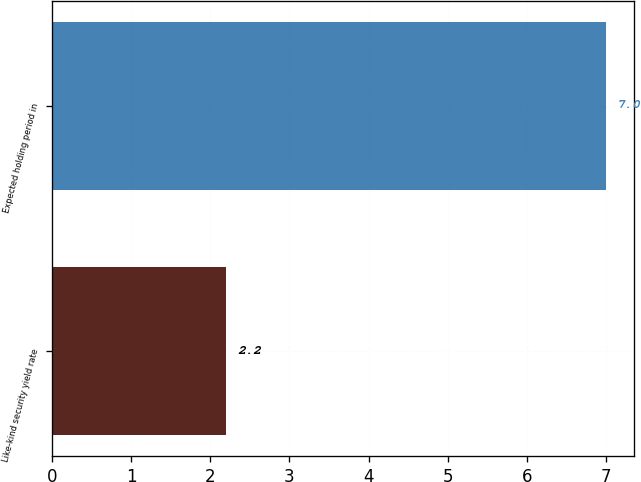Convert chart. <chart><loc_0><loc_0><loc_500><loc_500><bar_chart><fcel>Like-kind security yield rate<fcel>Expected holding period in<nl><fcel>2.2<fcel>7<nl></chart> 